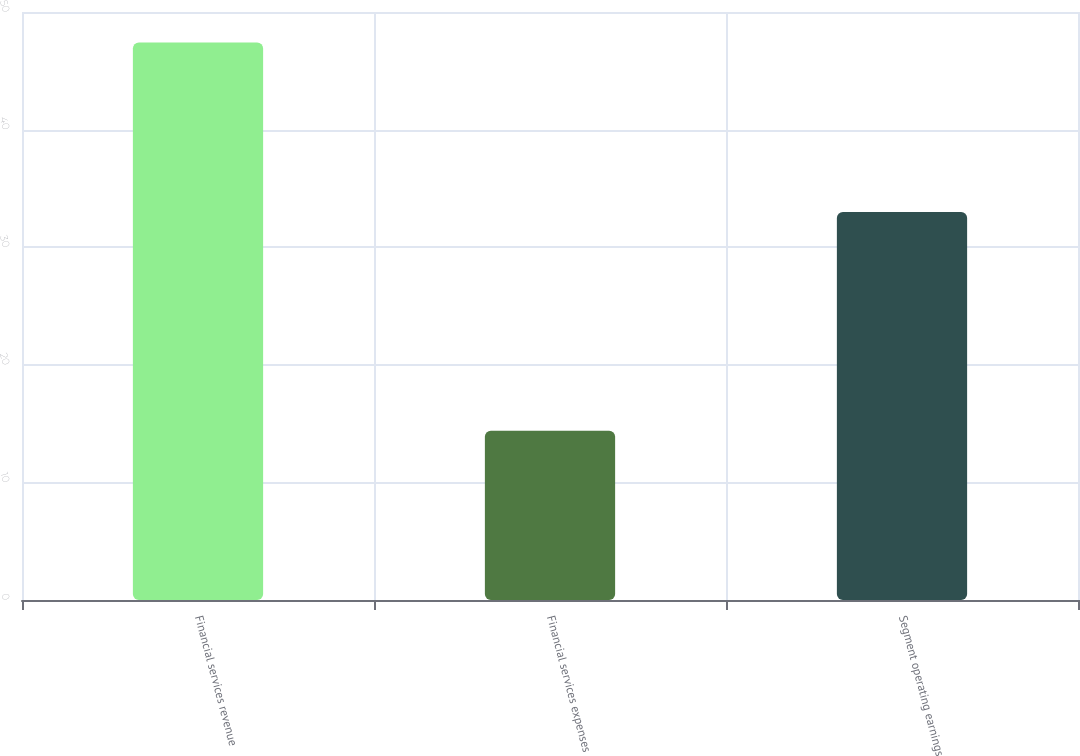Convert chart to OTSL. <chart><loc_0><loc_0><loc_500><loc_500><bar_chart><fcel>Financial services revenue<fcel>Financial services expenses<fcel>Segment operating earnings<nl><fcel>47.4<fcel>14.4<fcel>33<nl></chart> 